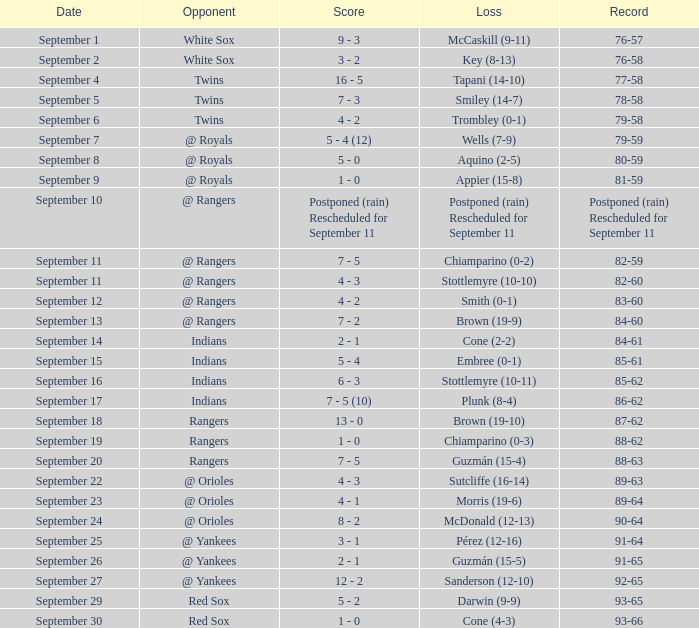What was the outcome of the game on september 15 featuring the indians as the opposing team? 5 - 4. 